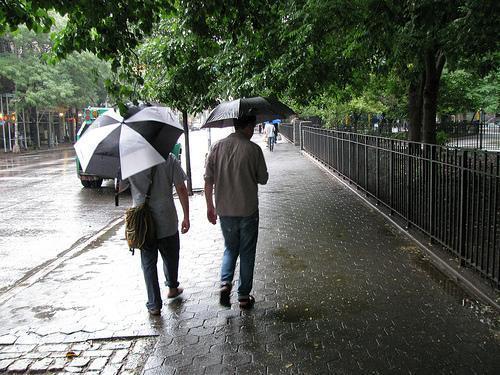How many people have umbrellas?
Give a very brief answer. 2. How many blue umbrellas are there?
Give a very brief answer. 1. 